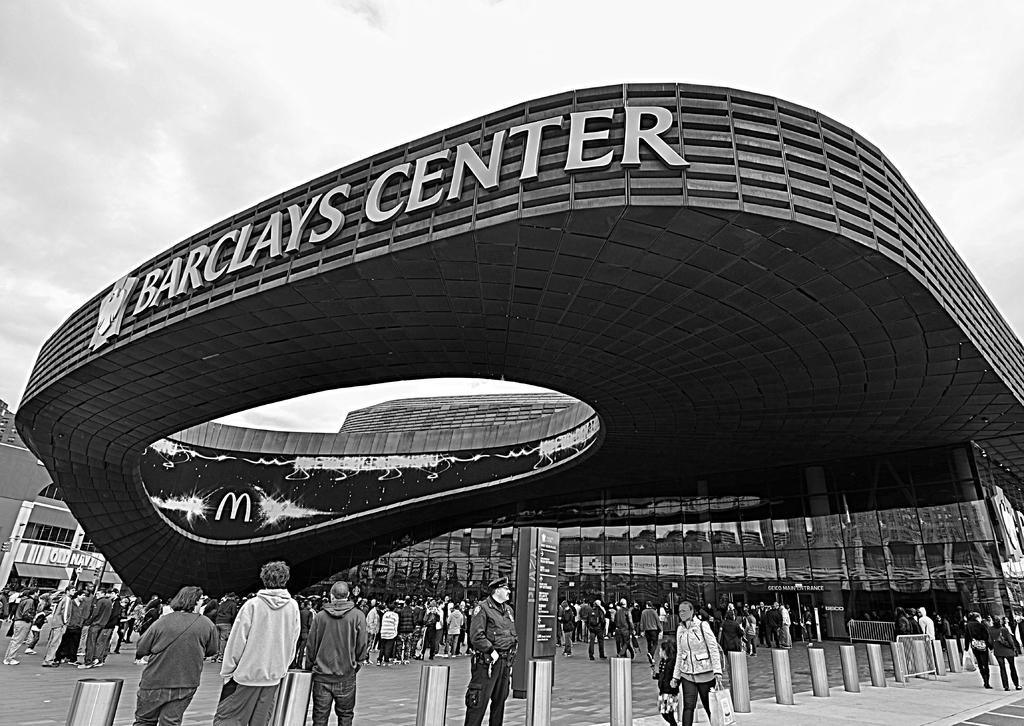What is the color scheme of the image? The image is black and white. What can be seen in the foreground of the image? There is a group of people standing in the image. What are some people doing in the image? Some people are walking on a path in the image. What can be seen in the background of the image? There are buildings and the sky visible in the background of the image. What type of bubble is floating in the image? There is no bubble present in the image. What shape is the square that the people are standing on in the image? There is no square present in the image; the people are standing on a path. 